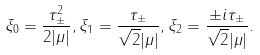Convert formula to latex. <formula><loc_0><loc_0><loc_500><loc_500>\xi _ { 0 } = \frac { \tau _ { \pm } ^ { 2 } } { 2 | \mu | } , \xi _ { 1 } = \frac { \tau _ { \pm } } { \sqrt { 2 } | \mu | } , \xi _ { 2 } = \frac { \pm i \tau _ { \pm } } { \sqrt { 2 } | \mu | } .</formula> 